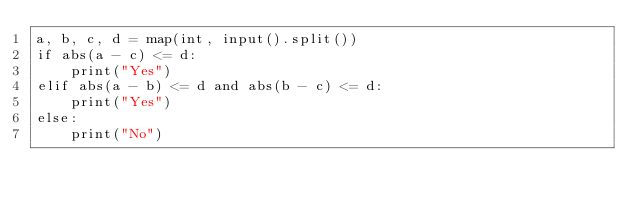Convert code to text. <code><loc_0><loc_0><loc_500><loc_500><_Python_>a, b, c, d = map(int, input().split())
if abs(a - c) <= d:
    print("Yes")
elif abs(a - b) <= d and abs(b - c) <= d:
    print("Yes")
else:
    print("No")</code> 